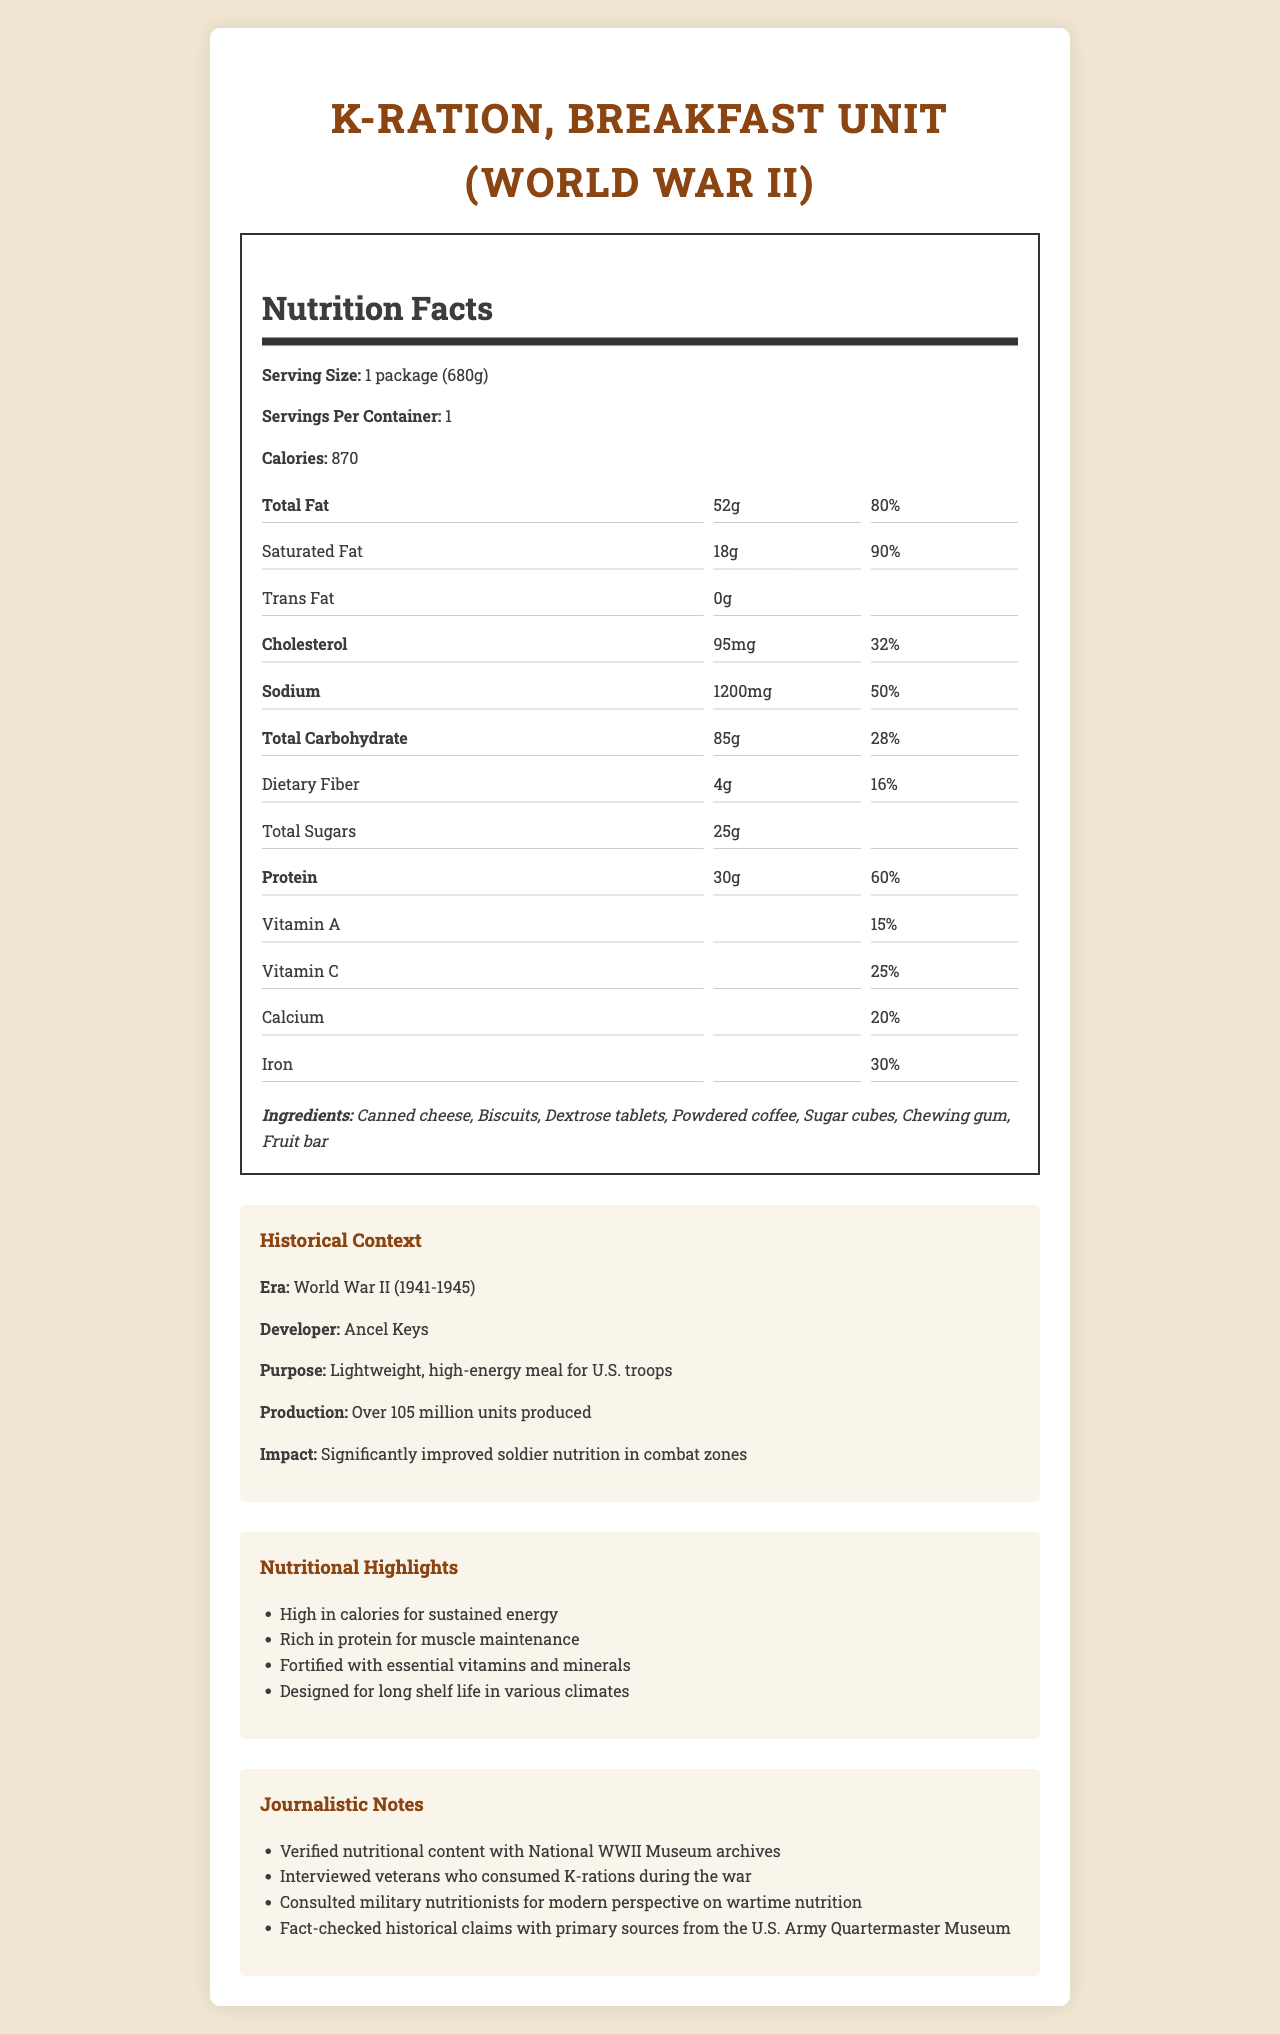what is the serving size of the K-Ration, Breakfast Unit? The serving size is listed as "1 package (680g)" in the document.
Answer: 1 package (680g) how many calories does one serving provide? The document states that there are 870 calories per serving.
Answer: 870 what percentage of the daily value of total fat does one serving contain? The document lists the total fat as "52g" and "80%" of the daily value.
Answer: 80% how much protein is in one serving? The document mentions that there are 30g of protein per serving, which is 60% of the daily value.
Answer: 30g what is the purpose of the K-Ration, Breakfast Unit during World War II? The document states that the purpose of the K-Ration was to provide a lightweight, high-energy meal for U.S. troops.
Answer: Lightweight, high-energy meal for U.S. troops which of the following ingredients are included in the K-Ration, Breakfast Unit? A. Canned cheese, Biscuits, Dextrose tablets B. Powdered coffee, Sugar cubes, Chewing gum C. Fruit bar, Dried meat, Crackers D. A and B E. All of the above The document lists the ingredients as "Canned cheese, Biscuits, Dextrose tablets, Powdered coffee, Sugar cubes, Chewing gum, Fruit bar."
Answer: D. A and B how much sodium is in one serving of the K-Ration? A. 800mg B. 1000mg C. 1200mg D. 1500mg The document states that there are 1200mg of sodium per serving.
Answer: C. 1200mg are there any trans fats in the K-Ration, Breakfast Unit? The document lists trans fat as "0g".
Answer: No did the K-Ration contain high quantities of vitamins and minerals? The document indicates that the K-Ration was "fortified with essential vitamins and minerals" and lists specific percentages for Vitamin A, Vitamin C, Calcium, and Iron.
Answer: Yes summarize the historical significance and nutritional content of the K-Ration, Breakfast Unit. This summary covers the product's purpose, nutritional highlights, ingredients, historical context, and its impact on soldiers' nutrition during the war.
Answer: The K-Ration, Breakfast Unit was designed as a lightweight, high-energy meal for U.S. troops during World War II, developed by Ancel Keys. It provided 870 calories per serving, with high amounts of protein (30g), fat (52g), and carbohydrates (85g). The K-Ration was fortified with essential vitamins and minerals and included ingredients such as canned cheese, biscuits, and powdered coffee. It significantly improved soldier nutrition and was produced in large quantities (over 105 million units). is the information about the developer of the K-Ration included in the document? The historical context section of the document mentions that the K-Ration was developed by Ancel Keys.
Answer: Yes how many servings are in one container of the K-Ration, Breakfast Unit? The document notes that there is one serving per container.
Answer: 1 are sugar cubes listed as an ingredient in the K-Ration, Breakfast Unit? Sugar cubes are listed among the ingredients in the document.
Answer: Yes how did the K-Ration impact soldier nutrition during World War II? The historical context section of the document mentions that the K-Ration significantly improved soldier nutrition in combat zones.
Answer: Significantly improved soldier nutrition in combat zones what main nutritional elements contribute to the high energy provided by the K-Ration? The K-Ration provides 870 calories and is rich in protein (30g) and fortified with essential vitamins and minerals, all of which contribute to the high energy.
Answer: Calories, protein, and fortified vitamins and minerals how much dietary fiber is in one serving of the K-Ration, Breakfast Unit? The document states that there are 4g of dietary fiber in one serving.
Answer: 4g who verified the nutritional content of the K-Ration? The document notes that the nutritional content was verified with National WWII Museum archives.
Answer: National WWII Museum archives how many units of the K-Ration were produced during World War II? The historical context section mentions that over 105 million units were produced.
Answer: Over 105 million units is there a mention of how long the K-Ration can last under various climates in the document? The document mentions that the K-Ration was designed for long shelf life in various climates.
Answer: Yes what is the ratio of saturated fat to total fat in one serving of the K-Ration, Breakfast Unit? One serving contains 18g of saturated fat and 52g of total fat, so the ratio is 18g to 52g, which simplifies to approximately 1:2.89.
Answer: Approximately 1:2.89 what percentage of the daily value of iron does the K-Ration provide? The document lists iron as providing 30% of the daily value.
Answer: 30% which specific historical sources were consulted for fact-checking the claims in the document? The document states that historical claims were fact-checked with primary sources from the U.S. Army Quartermaster Museum.
Answer: Primary sources from the U.S. Army Quartermaster Museum do we know the precise taste quality of the K-Ration, Breakfast Unit? The document provides detailed nutritional information and historical context but does not describe the precise taste quality of the ration.
Answer: Cannot be determined 